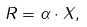Convert formula to latex. <formula><loc_0><loc_0><loc_500><loc_500>R = \alpha \cdot X ,</formula> 